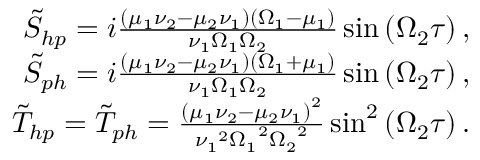<formula> <loc_0><loc_0><loc_500><loc_500>\begin{array} { r l r } & { \tilde { S } _ { h p } = i \frac { \left ( \mu _ { 1 } \nu _ { 2 } - \mu _ { 2 } \nu _ { 1 } \right ) \left ( \Omega _ { 1 } - \mu _ { 1 } \right ) } { \nu _ { 1 } \Omega _ { 1 } \Omega _ { 2 } } \sin \left ( \Omega _ { 2 } \tau \right ) , } \\ & { \tilde { S } _ { p h } = i \frac { \left ( \mu _ { 1 } \nu _ { 2 } - \mu _ { 2 } \nu _ { 1 } \right ) \left ( \Omega _ { 1 } + \mu _ { 1 } \right ) } { \nu _ { 1 } \Omega _ { 1 } \Omega _ { 2 } } \sin \left ( \Omega _ { 2 } \tau \right ) , } \\ & { \tilde { T } _ { h p } = \tilde { T } _ { p h } = \frac { \left ( \mu _ { 1 } \nu _ { 2 } - \mu _ { 2 } \nu _ { 1 } \right ) ^ { 2 } } { { \nu _ { 1 } } ^ { 2 } { \Omega _ { 1 } } ^ { 2 } { \Omega _ { 2 } } ^ { 2 } } \sin ^ { 2 } \left ( \Omega _ { 2 } \tau \right ) . } \end{array}</formula> 